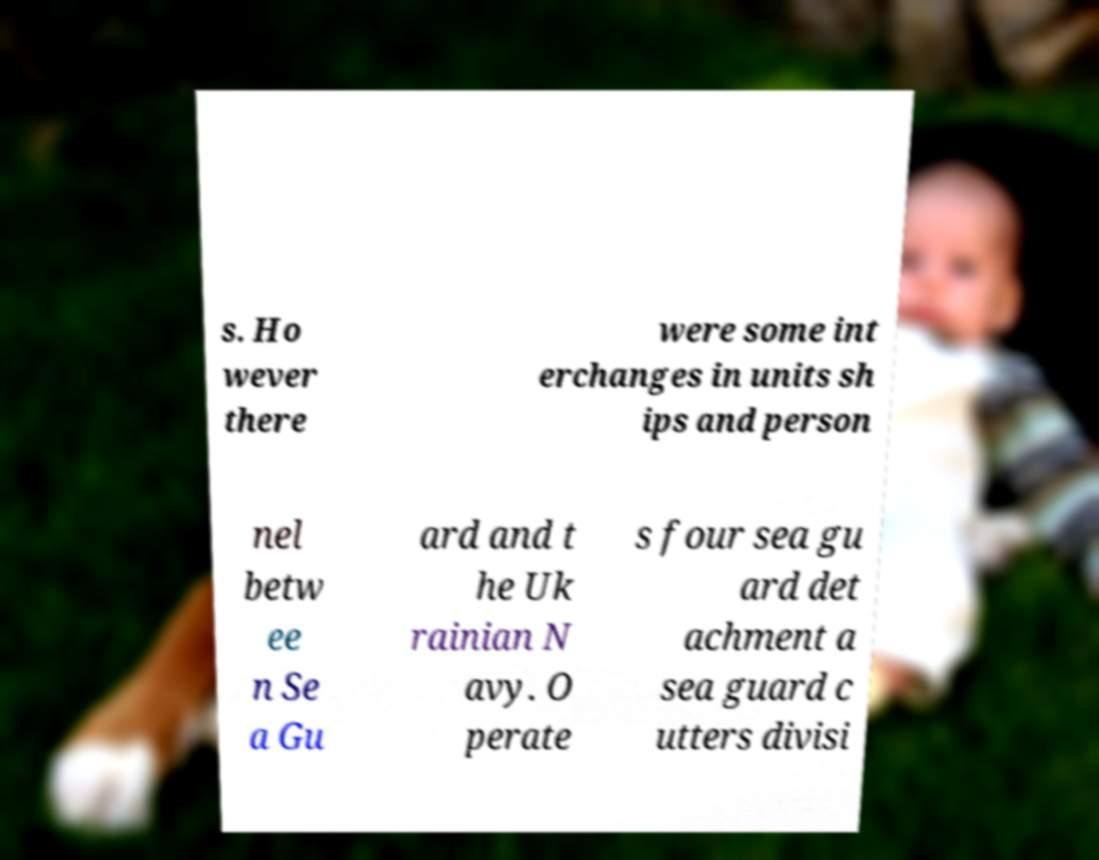Can you read and provide the text displayed in the image?This photo seems to have some interesting text. Can you extract and type it out for me? s. Ho wever there were some int erchanges in units sh ips and person nel betw ee n Se a Gu ard and t he Uk rainian N avy. O perate s four sea gu ard det achment a sea guard c utters divisi 